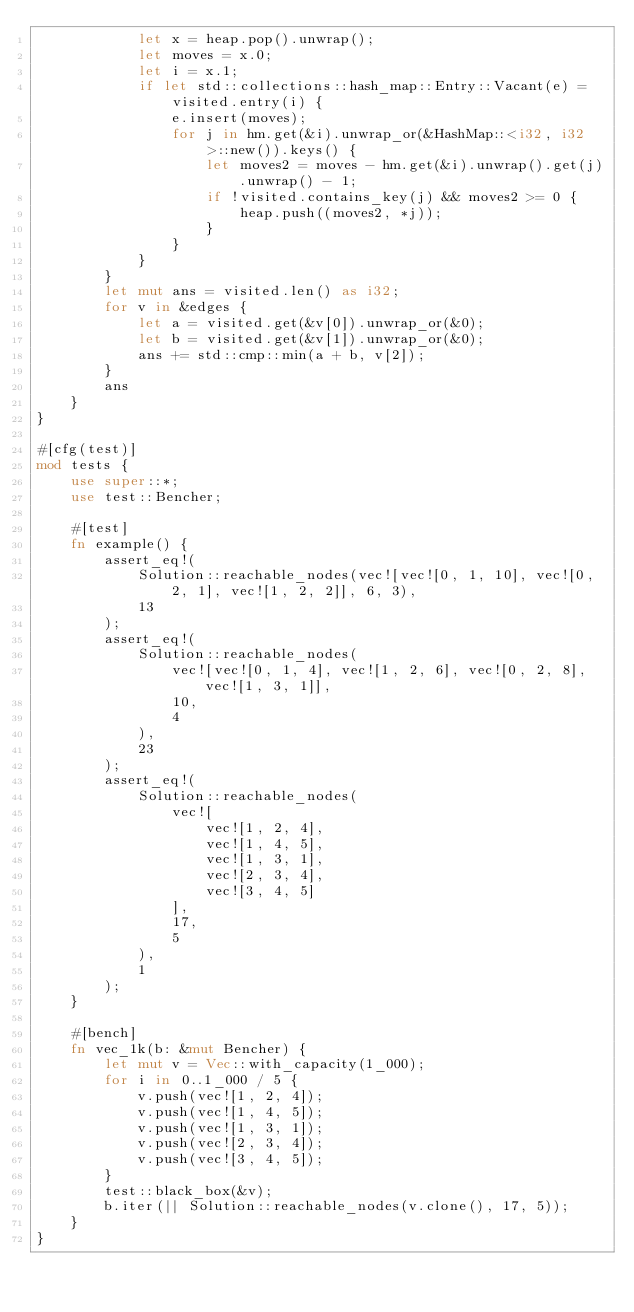<code> <loc_0><loc_0><loc_500><loc_500><_Rust_>            let x = heap.pop().unwrap();
            let moves = x.0;
            let i = x.1;
            if let std::collections::hash_map::Entry::Vacant(e) = visited.entry(i) {
                e.insert(moves);
                for j in hm.get(&i).unwrap_or(&HashMap::<i32, i32>::new()).keys() {
                    let moves2 = moves - hm.get(&i).unwrap().get(j).unwrap() - 1;
                    if !visited.contains_key(j) && moves2 >= 0 {
                        heap.push((moves2, *j));
                    }
                }
            }
        }
        let mut ans = visited.len() as i32;
        for v in &edges {
            let a = visited.get(&v[0]).unwrap_or(&0);
            let b = visited.get(&v[1]).unwrap_or(&0);
            ans += std::cmp::min(a + b, v[2]);
        }
        ans
    }
}

#[cfg(test)]
mod tests {
    use super::*;
    use test::Bencher;

    #[test]
    fn example() {
        assert_eq!(
            Solution::reachable_nodes(vec![vec![0, 1, 10], vec![0, 2, 1], vec![1, 2, 2]], 6, 3),
            13
        );
        assert_eq!(
            Solution::reachable_nodes(
                vec![vec![0, 1, 4], vec![1, 2, 6], vec![0, 2, 8], vec![1, 3, 1]],
                10,
                4
            ),
            23
        );
        assert_eq!(
            Solution::reachable_nodes(
                vec![
                    vec![1, 2, 4],
                    vec![1, 4, 5],
                    vec![1, 3, 1],
                    vec![2, 3, 4],
                    vec![3, 4, 5]
                ],
                17,
                5
            ),
            1
        );
    }

    #[bench]
    fn vec_1k(b: &mut Bencher) {
        let mut v = Vec::with_capacity(1_000);
        for i in 0..1_000 / 5 {
            v.push(vec![1, 2, 4]);
            v.push(vec![1, 4, 5]);
            v.push(vec![1, 3, 1]);
            v.push(vec![2, 3, 4]);
            v.push(vec![3, 4, 5]);
        }
        test::black_box(&v);
        b.iter(|| Solution::reachable_nodes(v.clone(), 17, 5));
    }
}
</code> 